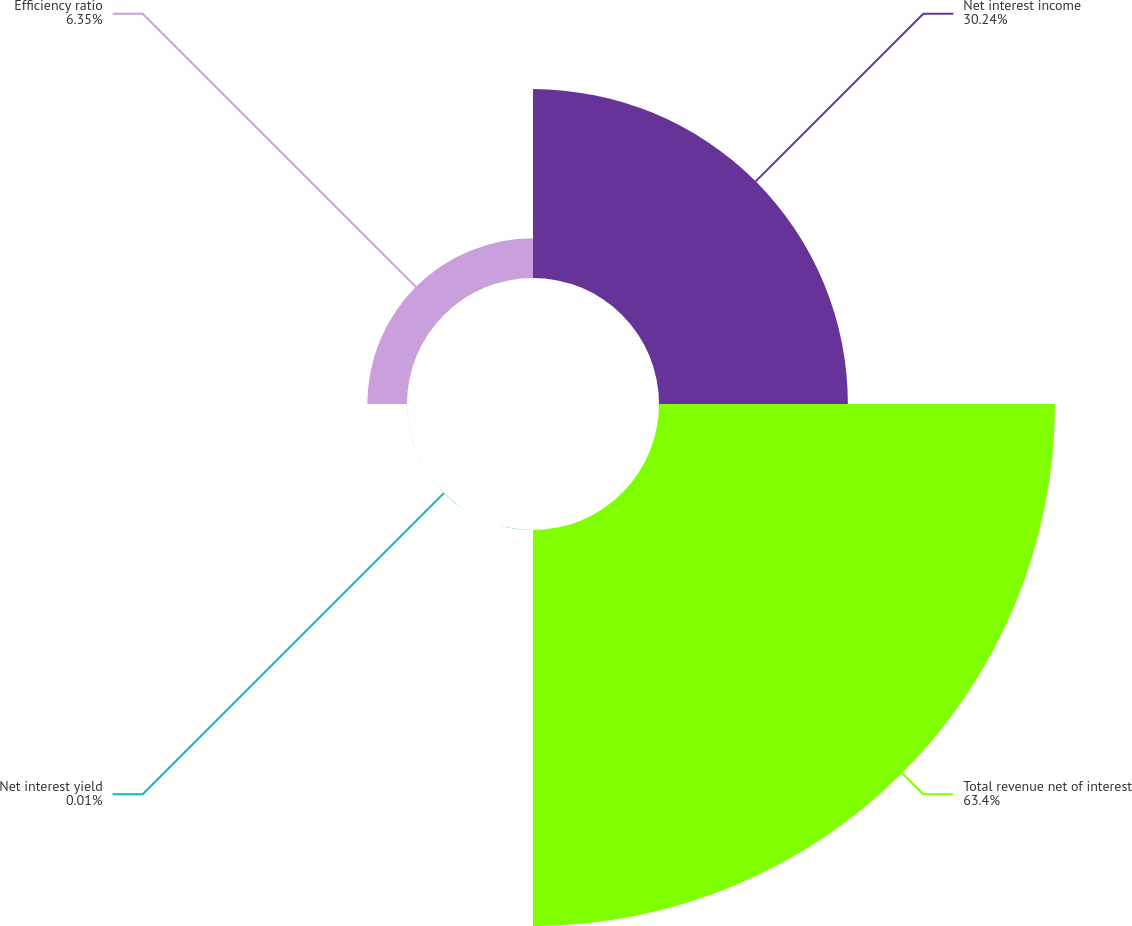Convert chart to OTSL. <chart><loc_0><loc_0><loc_500><loc_500><pie_chart><fcel>Net interest income<fcel>Total revenue net of interest<fcel>Net interest yield<fcel>Efficiency ratio<nl><fcel>30.24%<fcel>63.4%<fcel>0.01%<fcel>6.35%<nl></chart> 